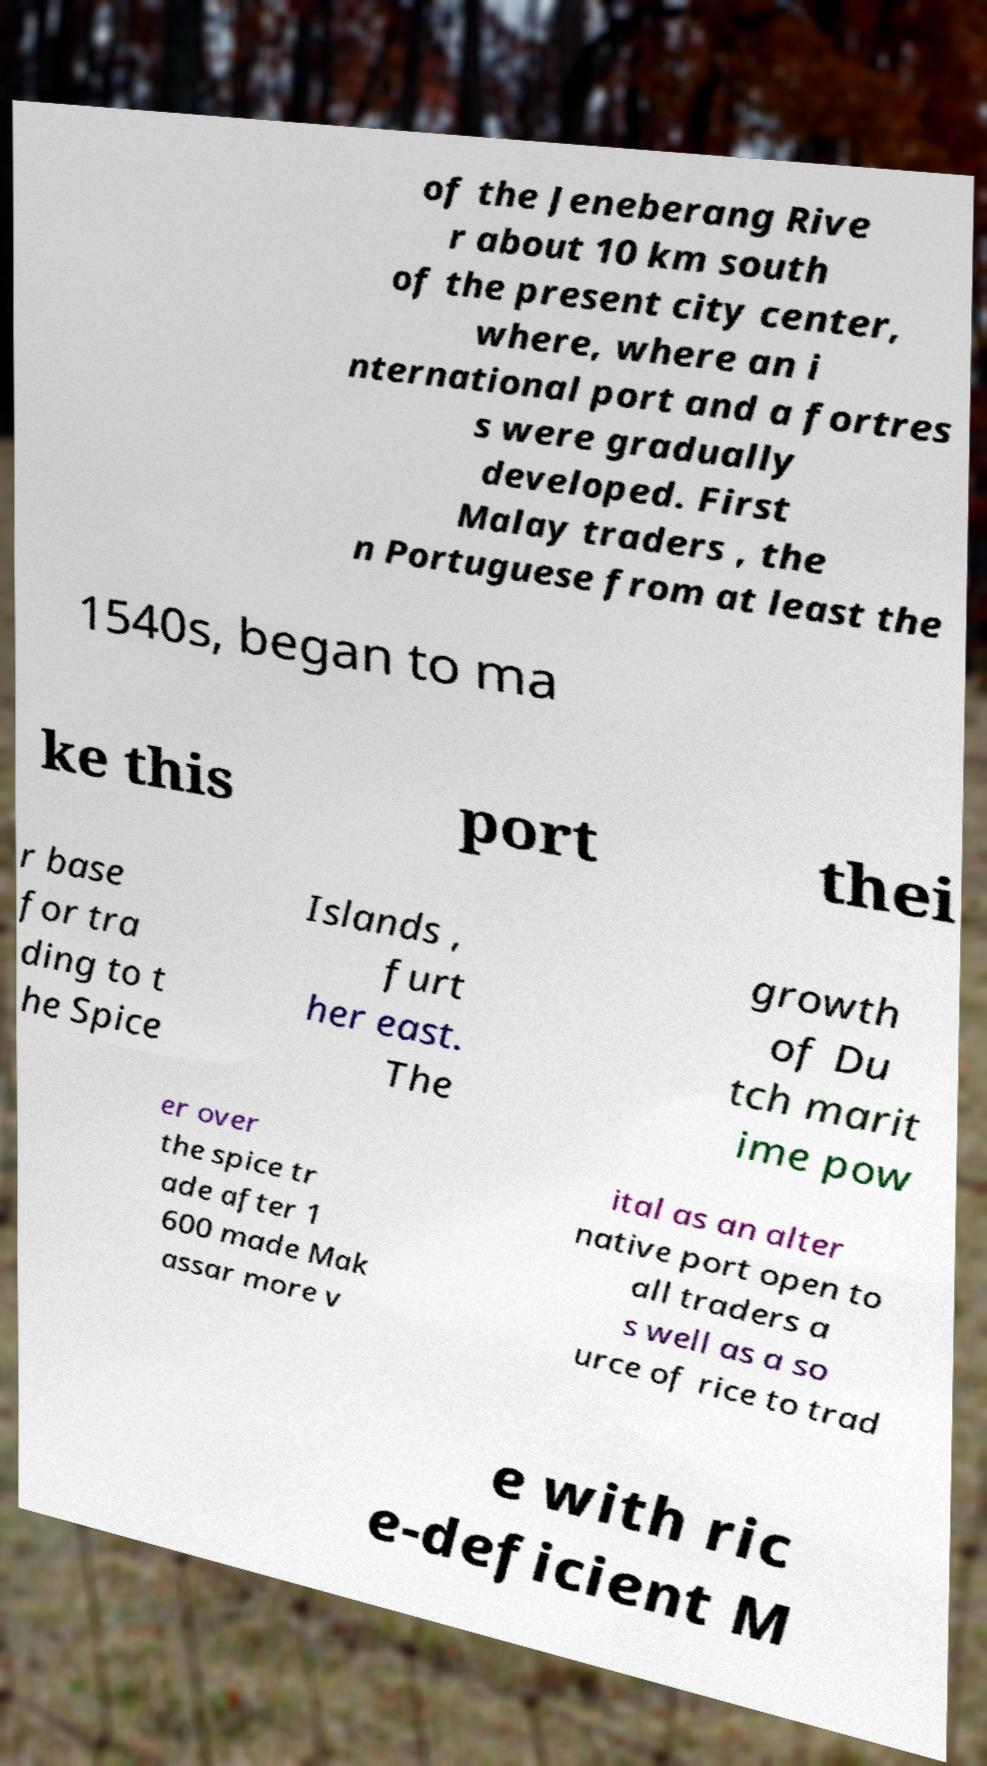Can you accurately transcribe the text from the provided image for me? of the Jeneberang Rive r about 10 km south of the present city center, where, where an i nternational port and a fortres s were gradually developed. First Malay traders , the n Portuguese from at least the 1540s, began to ma ke this port thei r base for tra ding to t he Spice Islands , furt her east. The growth of Du tch marit ime pow er over the spice tr ade after 1 600 made Mak assar more v ital as an alter native port open to all traders a s well as a so urce of rice to trad e with ric e-deficient M 